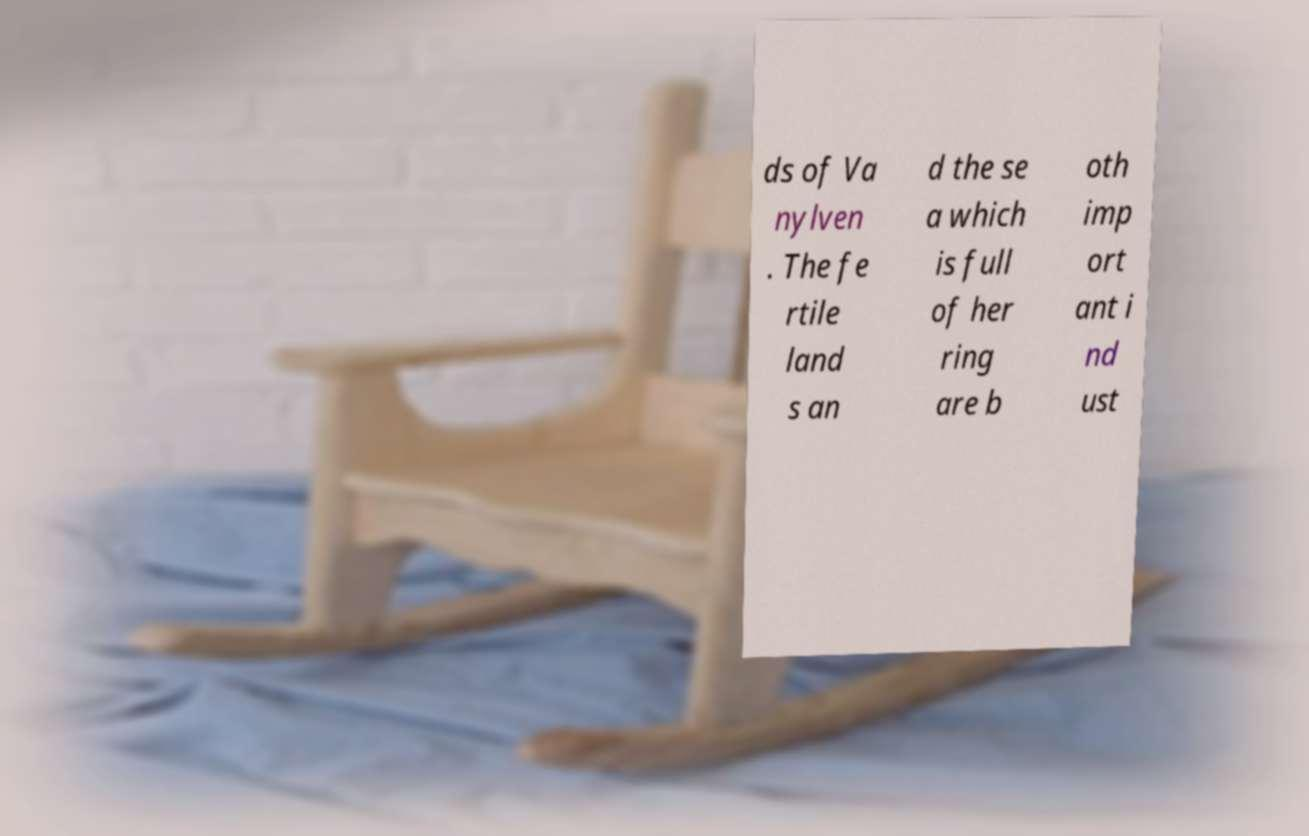Could you assist in decoding the text presented in this image and type it out clearly? ds of Va nylven . The fe rtile land s an d the se a which is full of her ring are b oth imp ort ant i nd ust 